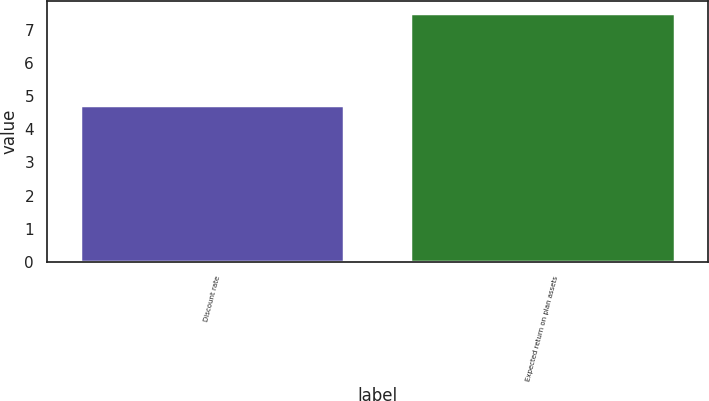Convert chart. <chart><loc_0><loc_0><loc_500><loc_500><bar_chart><fcel>Discount rate<fcel>Expected return on plan assets<nl><fcel>4.72<fcel>7.5<nl></chart> 